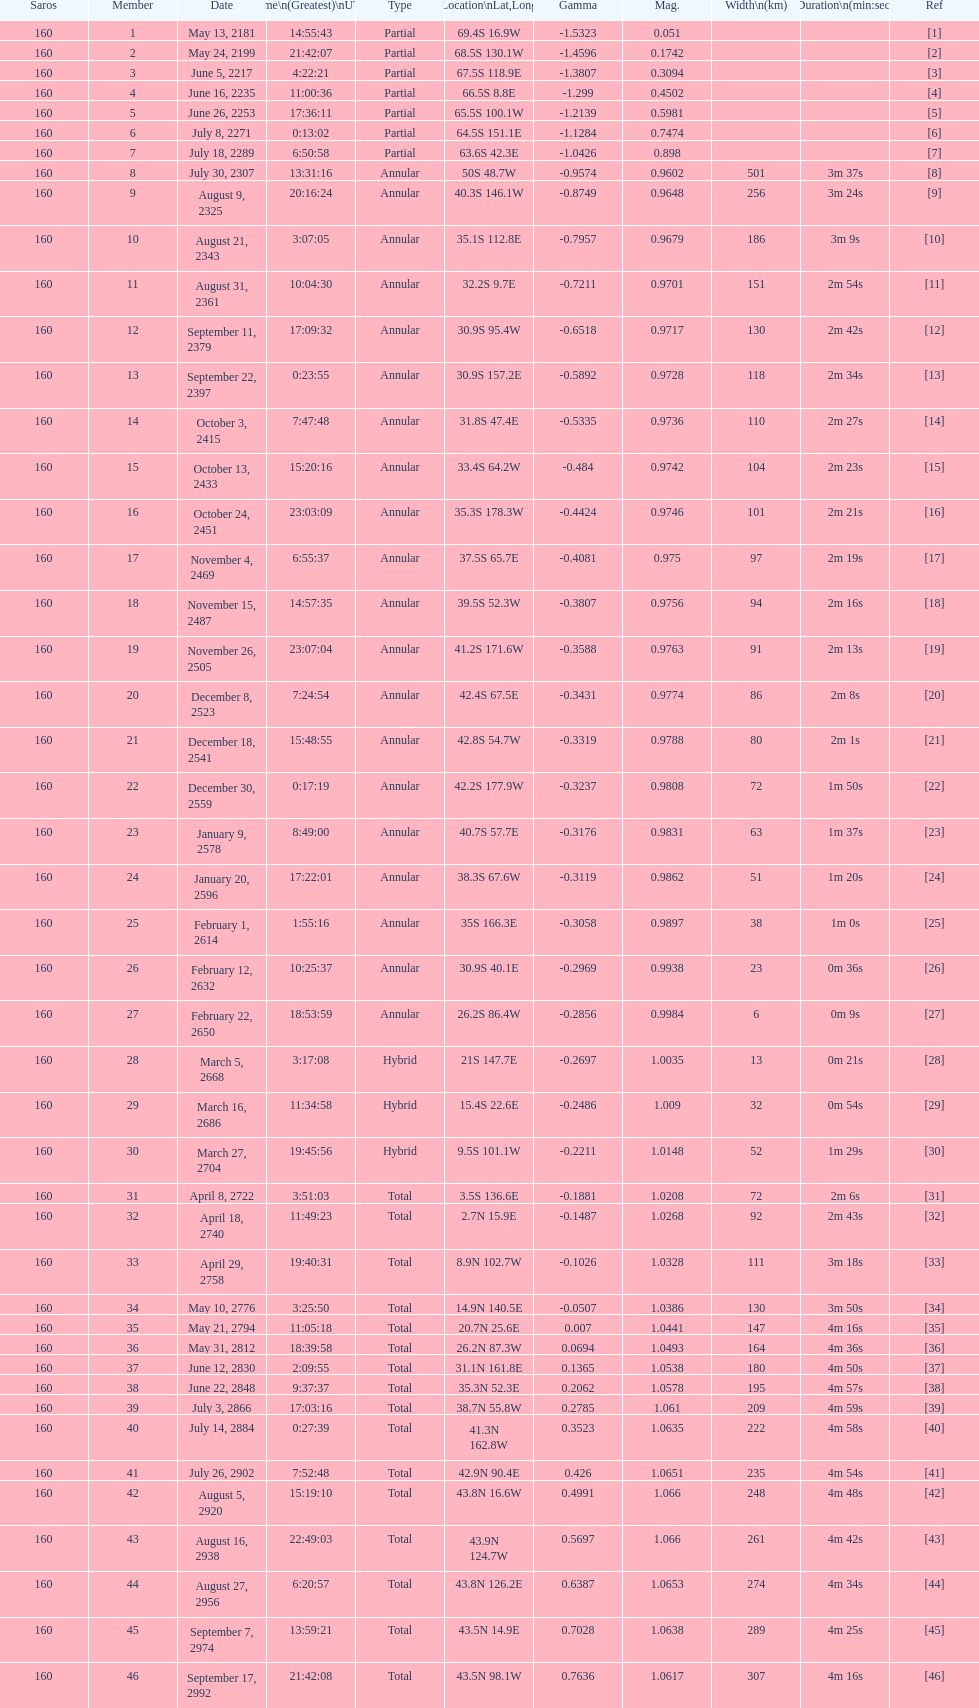What will be the cumulative number of events occurring? 46. Parse the table in full. {'header': ['Saros', 'Member', 'Date', 'Time\\n(Greatest)\\nUTC', 'Type', 'Location\\nLat,Long', 'Gamma', 'Mag.', 'Width\\n(km)', 'Duration\\n(min:sec)', 'Ref'], 'rows': [['160', '1', 'May 13, 2181', '14:55:43', 'Partial', '69.4S 16.9W', '-1.5323', '0.051', '', '', '[1]'], ['160', '2', 'May 24, 2199', '21:42:07', 'Partial', '68.5S 130.1W', '-1.4596', '0.1742', '', '', '[2]'], ['160', '3', 'June 5, 2217', '4:22:21', 'Partial', '67.5S 118.9E', '-1.3807', '0.3094', '', '', '[3]'], ['160', '4', 'June 16, 2235', '11:00:36', 'Partial', '66.5S 8.8E', '-1.299', '0.4502', '', '', '[4]'], ['160', '5', 'June 26, 2253', '17:36:11', 'Partial', '65.5S 100.1W', '-1.2139', '0.5981', '', '', '[5]'], ['160', '6', 'July 8, 2271', '0:13:02', 'Partial', '64.5S 151.1E', '-1.1284', '0.7474', '', '', '[6]'], ['160', '7', 'July 18, 2289', '6:50:58', 'Partial', '63.6S 42.3E', '-1.0426', '0.898', '', '', '[7]'], ['160', '8', 'July 30, 2307', '13:31:16', 'Annular', '50S 48.7W', '-0.9574', '0.9602', '501', '3m 37s', '[8]'], ['160', '9', 'August 9, 2325', '20:16:24', 'Annular', '40.3S 146.1W', '-0.8749', '0.9648', '256', '3m 24s', '[9]'], ['160', '10', 'August 21, 2343', '3:07:05', 'Annular', '35.1S 112.8E', '-0.7957', '0.9679', '186', '3m 9s', '[10]'], ['160', '11', 'August 31, 2361', '10:04:30', 'Annular', '32.2S 9.7E', '-0.7211', '0.9701', '151', '2m 54s', '[11]'], ['160', '12', 'September 11, 2379', '17:09:32', 'Annular', '30.9S 95.4W', '-0.6518', '0.9717', '130', '2m 42s', '[12]'], ['160', '13', 'September 22, 2397', '0:23:55', 'Annular', '30.9S 157.2E', '-0.5892', '0.9728', '118', '2m 34s', '[13]'], ['160', '14', 'October 3, 2415', '7:47:48', 'Annular', '31.8S 47.4E', '-0.5335', '0.9736', '110', '2m 27s', '[14]'], ['160', '15', 'October 13, 2433', '15:20:16', 'Annular', '33.4S 64.2W', '-0.484', '0.9742', '104', '2m 23s', '[15]'], ['160', '16', 'October 24, 2451', '23:03:09', 'Annular', '35.3S 178.3W', '-0.4424', '0.9746', '101', '2m 21s', '[16]'], ['160', '17', 'November 4, 2469', '6:55:37', 'Annular', '37.5S 65.7E', '-0.4081', '0.975', '97', '2m 19s', '[17]'], ['160', '18', 'November 15, 2487', '14:57:35', 'Annular', '39.5S 52.3W', '-0.3807', '0.9756', '94', '2m 16s', '[18]'], ['160', '19', 'November 26, 2505', '23:07:04', 'Annular', '41.2S 171.6W', '-0.3588', '0.9763', '91', '2m 13s', '[19]'], ['160', '20', 'December 8, 2523', '7:24:54', 'Annular', '42.4S 67.5E', '-0.3431', '0.9774', '86', '2m 8s', '[20]'], ['160', '21', 'December 18, 2541', '15:48:55', 'Annular', '42.8S 54.7W', '-0.3319', '0.9788', '80', '2m 1s', '[21]'], ['160', '22', 'December 30, 2559', '0:17:19', 'Annular', '42.2S 177.9W', '-0.3237', '0.9808', '72', '1m 50s', '[22]'], ['160', '23', 'January 9, 2578', '8:49:00', 'Annular', '40.7S 57.7E', '-0.3176', '0.9831', '63', '1m 37s', '[23]'], ['160', '24', 'January 20, 2596', '17:22:01', 'Annular', '38.3S 67.6W', '-0.3119', '0.9862', '51', '1m 20s', '[24]'], ['160', '25', 'February 1, 2614', '1:55:16', 'Annular', '35S 166.3E', '-0.3058', '0.9897', '38', '1m 0s', '[25]'], ['160', '26', 'February 12, 2632', '10:25:37', 'Annular', '30.9S 40.1E', '-0.2969', '0.9938', '23', '0m 36s', '[26]'], ['160', '27', 'February 22, 2650', '18:53:59', 'Annular', '26.2S 86.4W', '-0.2856', '0.9984', '6', '0m 9s', '[27]'], ['160', '28', 'March 5, 2668', '3:17:08', 'Hybrid', '21S 147.7E', '-0.2697', '1.0035', '13', '0m 21s', '[28]'], ['160', '29', 'March 16, 2686', '11:34:58', 'Hybrid', '15.4S 22.6E', '-0.2486', '1.009', '32', '0m 54s', '[29]'], ['160', '30', 'March 27, 2704', '19:45:56', 'Hybrid', '9.5S 101.1W', '-0.2211', '1.0148', '52', '1m 29s', '[30]'], ['160', '31', 'April 8, 2722', '3:51:03', 'Total', '3.5S 136.6E', '-0.1881', '1.0208', '72', '2m 6s', '[31]'], ['160', '32', 'April 18, 2740', '11:49:23', 'Total', '2.7N 15.9E', '-0.1487', '1.0268', '92', '2m 43s', '[32]'], ['160', '33', 'April 29, 2758', '19:40:31', 'Total', '8.9N 102.7W', '-0.1026', '1.0328', '111', '3m 18s', '[33]'], ['160', '34', 'May 10, 2776', '3:25:50', 'Total', '14.9N 140.5E', '-0.0507', '1.0386', '130', '3m 50s', '[34]'], ['160', '35', 'May 21, 2794', '11:05:18', 'Total', '20.7N 25.6E', '0.007', '1.0441', '147', '4m 16s', '[35]'], ['160', '36', 'May 31, 2812', '18:39:58', 'Total', '26.2N 87.3W', '0.0694', '1.0493', '164', '4m 36s', '[36]'], ['160', '37', 'June 12, 2830', '2:09:55', 'Total', '31.1N 161.8E', '0.1365', '1.0538', '180', '4m 50s', '[37]'], ['160', '38', 'June 22, 2848', '9:37:37', 'Total', '35.3N 52.3E', '0.2062', '1.0578', '195', '4m 57s', '[38]'], ['160', '39', 'July 3, 2866', '17:03:16', 'Total', '38.7N 55.8W', '0.2785', '1.061', '209', '4m 59s', '[39]'], ['160', '40', 'July 14, 2884', '0:27:39', 'Total', '41.3N 162.8W', '0.3523', '1.0635', '222', '4m 58s', '[40]'], ['160', '41', 'July 26, 2902', '7:52:48', 'Total', '42.9N 90.4E', '0.426', '1.0651', '235', '4m 54s', '[41]'], ['160', '42', 'August 5, 2920', '15:19:10', 'Total', '43.8N 16.6W', '0.4991', '1.066', '248', '4m 48s', '[42]'], ['160', '43', 'August 16, 2938', '22:49:03', 'Total', '43.9N 124.7W', '0.5697', '1.066', '261', '4m 42s', '[43]'], ['160', '44', 'August 27, 2956', '6:20:57', 'Total', '43.8N 126.2E', '0.6387', '1.0653', '274', '4m 34s', '[44]'], ['160', '45', 'September 7, 2974', '13:59:21', 'Total', '43.5N 14.9E', '0.7028', '1.0638', '289', '4m 25s', '[45]'], ['160', '46', 'September 17, 2992', '21:42:08', 'Total', '43.5N 98.1W', '0.7636', '1.0617', '307', '4m 16s', '[46]']]} 